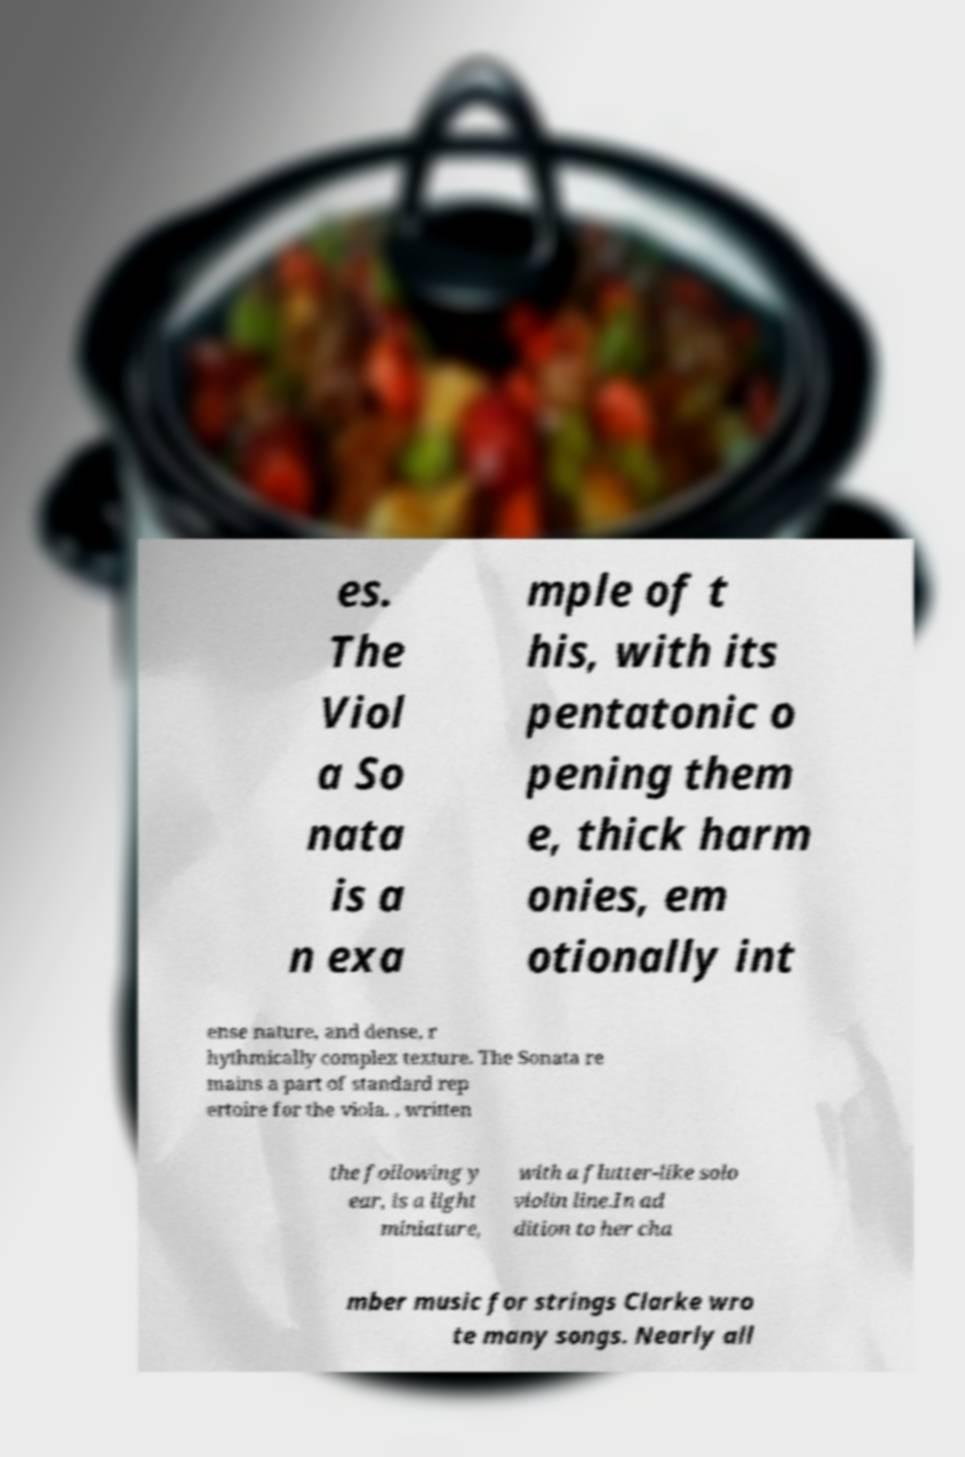Please identify and transcribe the text found in this image. es. The Viol a So nata is a n exa mple of t his, with its pentatonic o pening them e, thick harm onies, em otionally int ense nature, and dense, r hythmically complex texture. The Sonata re mains a part of standard rep ertoire for the viola. , written the following y ear, is a light miniature, with a flutter-like solo violin line.In ad dition to her cha mber music for strings Clarke wro te many songs. Nearly all 